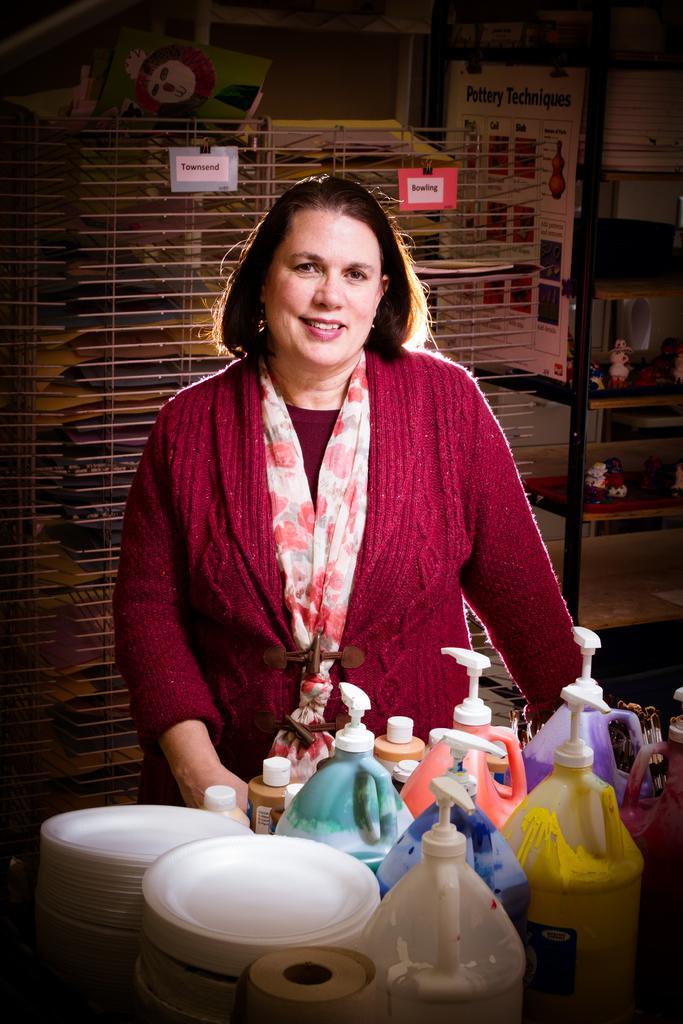How would you summarize this image in a sentence or two? On the background we can see a rack with paper notes. Here we can see a women standing in front of a table and she is carrying a pretty smile on her face. On the table we can see bottles, plate. 